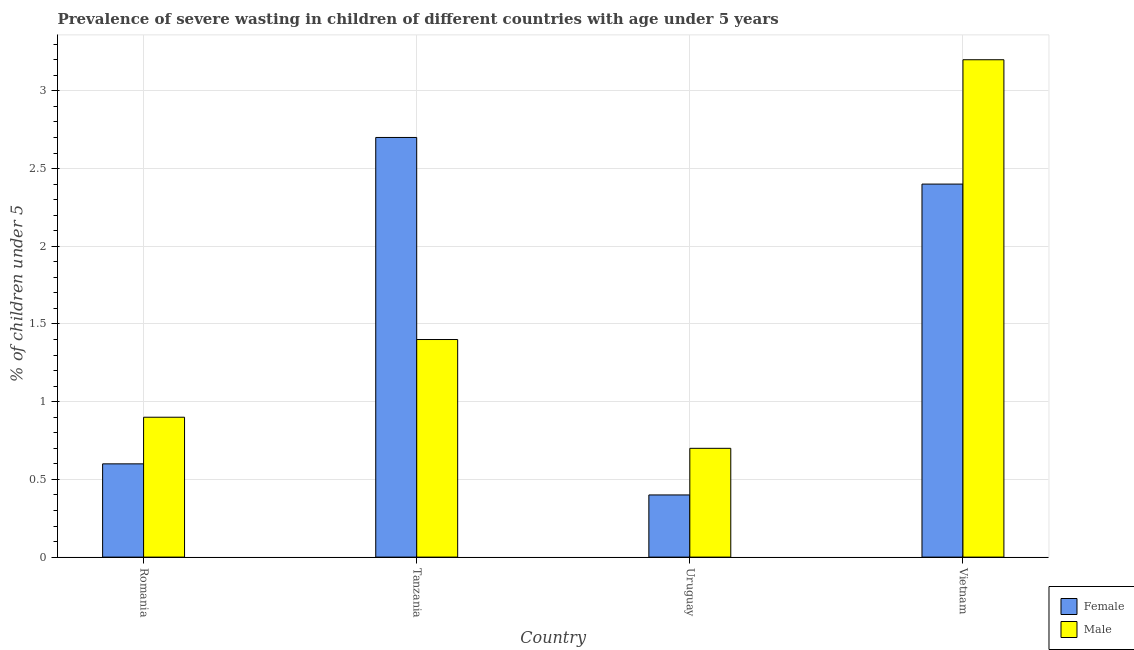How many groups of bars are there?
Your response must be concise. 4. Are the number of bars on each tick of the X-axis equal?
Ensure brevity in your answer.  Yes. What is the label of the 1st group of bars from the left?
Your response must be concise. Romania. In how many cases, is the number of bars for a given country not equal to the number of legend labels?
Give a very brief answer. 0. What is the percentage of undernourished male children in Tanzania?
Give a very brief answer. 1.4. Across all countries, what is the maximum percentage of undernourished male children?
Your answer should be very brief. 3.2. Across all countries, what is the minimum percentage of undernourished male children?
Your answer should be compact. 0.7. In which country was the percentage of undernourished female children maximum?
Keep it short and to the point. Tanzania. In which country was the percentage of undernourished male children minimum?
Offer a terse response. Uruguay. What is the total percentage of undernourished female children in the graph?
Ensure brevity in your answer.  6.1. What is the difference between the percentage of undernourished female children in Romania and that in Uruguay?
Ensure brevity in your answer.  0.2. What is the difference between the percentage of undernourished male children in Vietnam and the percentage of undernourished female children in Romania?
Keep it short and to the point. 2.6. What is the average percentage of undernourished female children per country?
Make the answer very short. 1.53. What is the difference between the percentage of undernourished female children and percentage of undernourished male children in Uruguay?
Ensure brevity in your answer.  -0.3. What is the ratio of the percentage of undernourished female children in Romania to that in Tanzania?
Provide a succinct answer. 0.22. Is the percentage of undernourished female children in Romania less than that in Vietnam?
Your answer should be compact. Yes. What is the difference between the highest and the second highest percentage of undernourished male children?
Keep it short and to the point. 1.8. What is the difference between the highest and the lowest percentage of undernourished male children?
Keep it short and to the point. 2.5. In how many countries, is the percentage of undernourished female children greater than the average percentage of undernourished female children taken over all countries?
Provide a succinct answer. 2. What does the 1st bar from the left in Romania represents?
Offer a terse response. Female. What does the 2nd bar from the right in Tanzania represents?
Keep it short and to the point. Female. Are all the bars in the graph horizontal?
Offer a very short reply. No. Are the values on the major ticks of Y-axis written in scientific E-notation?
Your response must be concise. No. Does the graph contain any zero values?
Provide a succinct answer. No. Does the graph contain grids?
Ensure brevity in your answer.  Yes. How are the legend labels stacked?
Keep it short and to the point. Vertical. What is the title of the graph?
Provide a succinct answer. Prevalence of severe wasting in children of different countries with age under 5 years. Does "Formally registered" appear as one of the legend labels in the graph?
Provide a short and direct response. No. What is the label or title of the X-axis?
Provide a short and direct response. Country. What is the label or title of the Y-axis?
Provide a short and direct response.  % of children under 5. What is the  % of children under 5 of Female in Romania?
Your response must be concise. 0.6. What is the  % of children under 5 in Male in Romania?
Make the answer very short. 0.9. What is the  % of children under 5 in Female in Tanzania?
Provide a succinct answer. 2.7. What is the  % of children under 5 of Male in Tanzania?
Provide a short and direct response. 1.4. What is the  % of children under 5 of Female in Uruguay?
Make the answer very short. 0.4. What is the  % of children under 5 in Male in Uruguay?
Provide a succinct answer. 0.7. What is the  % of children under 5 of Female in Vietnam?
Your answer should be compact. 2.4. What is the  % of children under 5 of Male in Vietnam?
Your response must be concise. 3.2. Across all countries, what is the maximum  % of children under 5 of Female?
Provide a short and direct response. 2.7. Across all countries, what is the maximum  % of children under 5 of Male?
Provide a short and direct response. 3.2. Across all countries, what is the minimum  % of children under 5 in Female?
Your answer should be very brief. 0.4. Across all countries, what is the minimum  % of children under 5 in Male?
Provide a short and direct response. 0.7. What is the difference between the  % of children under 5 in Female in Romania and that in Tanzania?
Offer a terse response. -2.1. What is the difference between the  % of children under 5 of Male in Romania and that in Tanzania?
Provide a succinct answer. -0.5. What is the difference between the  % of children under 5 of Male in Romania and that in Uruguay?
Provide a short and direct response. 0.2. What is the difference between the  % of children under 5 in Female in Romania and that in Vietnam?
Keep it short and to the point. -1.8. What is the difference between the  % of children under 5 in Male in Tanzania and that in Uruguay?
Your answer should be very brief. 0.7. What is the difference between the  % of children under 5 of Female in Uruguay and that in Vietnam?
Keep it short and to the point. -2. What is the difference between the  % of children under 5 in Female in Romania and the  % of children under 5 in Male in Tanzania?
Offer a very short reply. -0.8. What is the difference between the  % of children under 5 in Female in Romania and the  % of children under 5 in Male in Uruguay?
Ensure brevity in your answer.  -0.1. What is the difference between the  % of children under 5 in Female in Romania and the  % of children under 5 in Male in Vietnam?
Keep it short and to the point. -2.6. What is the difference between the  % of children under 5 of Female in Tanzania and the  % of children under 5 of Male in Uruguay?
Your answer should be very brief. 2. What is the average  % of children under 5 of Female per country?
Offer a very short reply. 1.52. What is the average  % of children under 5 of Male per country?
Provide a succinct answer. 1.55. What is the ratio of the  % of children under 5 of Female in Romania to that in Tanzania?
Your response must be concise. 0.22. What is the ratio of the  % of children under 5 in Male in Romania to that in Tanzania?
Offer a very short reply. 0.64. What is the ratio of the  % of children under 5 of Male in Romania to that in Uruguay?
Keep it short and to the point. 1.29. What is the ratio of the  % of children under 5 of Female in Romania to that in Vietnam?
Provide a succinct answer. 0.25. What is the ratio of the  % of children under 5 in Male in Romania to that in Vietnam?
Provide a succinct answer. 0.28. What is the ratio of the  % of children under 5 in Female in Tanzania to that in Uruguay?
Provide a short and direct response. 6.75. What is the ratio of the  % of children under 5 in Male in Tanzania to that in Uruguay?
Offer a very short reply. 2. What is the ratio of the  % of children under 5 in Female in Tanzania to that in Vietnam?
Provide a short and direct response. 1.12. What is the ratio of the  % of children under 5 in Male in Tanzania to that in Vietnam?
Your answer should be compact. 0.44. What is the ratio of the  % of children under 5 in Male in Uruguay to that in Vietnam?
Offer a very short reply. 0.22. What is the difference between the highest and the second highest  % of children under 5 in Female?
Offer a very short reply. 0.3. What is the difference between the highest and the lowest  % of children under 5 in Female?
Offer a very short reply. 2.3. What is the difference between the highest and the lowest  % of children under 5 of Male?
Offer a terse response. 2.5. 